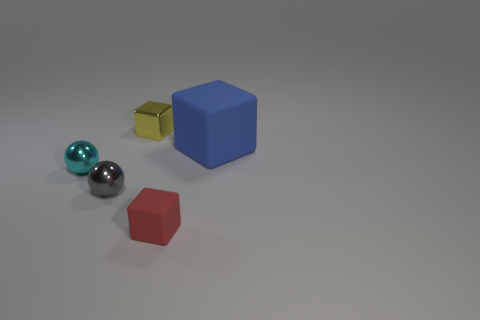Are there any other things that have the same size as the blue matte object?
Offer a terse response. No. There is a metallic object that is to the left of the gray metallic thing; is its size the same as the large blue cube?
Offer a very short reply. No. What size is the cube on the left side of the small red matte thing?
Your answer should be compact. Small. The other cube that is the same size as the red rubber cube is what color?
Provide a short and direct response. Yellow. Do the tiny object on the right side of the tiny yellow metallic block and the tiny cyan metallic object have the same shape?
Provide a succinct answer. No. What is the color of the tiny block in front of the small metallic object that is behind the cube that is to the right of the tiny red cube?
Your response must be concise. Red. Is there a small red matte ball?
Make the answer very short. No. What number of other objects are there of the same size as the gray metallic object?
Offer a terse response. 3. Do the big object and the block that is on the left side of the small red matte block have the same color?
Offer a terse response. No. What number of things are either blue rubber cubes or tiny gray objects?
Provide a succinct answer. 2. 